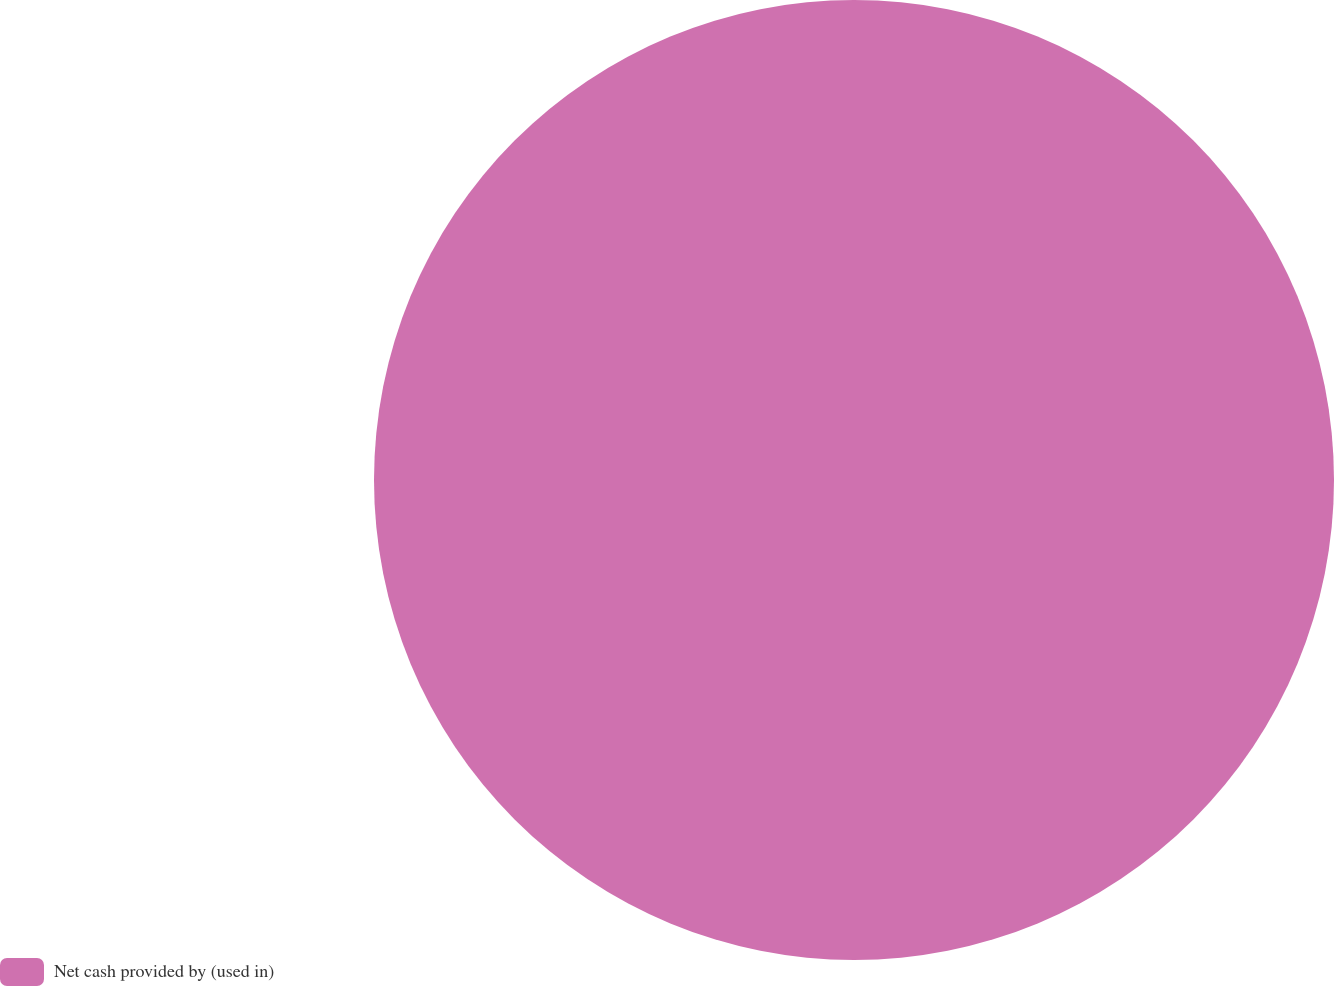<chart> <loc_0><loc_0><loc_500><loc_500><pie_chart><fcel>Net cash provided by (used in)<nl><fcel>100.0%<nl></chart> 